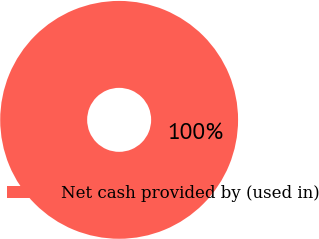<chart> <loc_0><loc_0><loc_500><loc_500><pie_chart><fcel>Net cash provided by (used in)<nl><fcel>100.0%<nl></chart> 